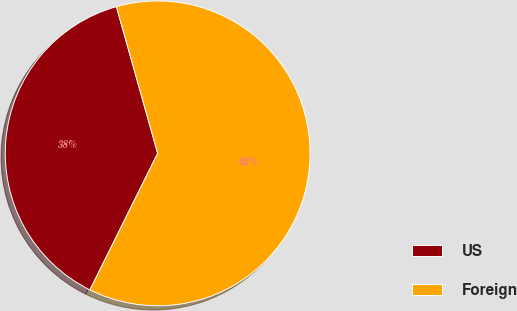<chart> <loc_0><loc_0><loc_500><loc_500><pie_chart><fcel>US<fcel>Foreign<nl><fcel>38.31%<fcel>61.69%<nl></chart> 